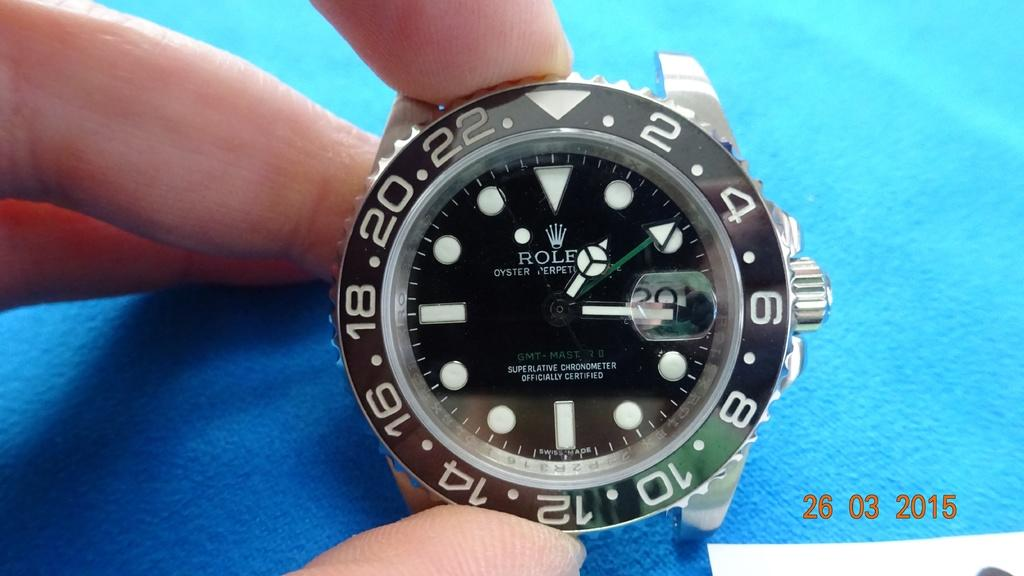Provide a one-sentence caption for the provided image. A close up of a Rolex watch from 2015. 